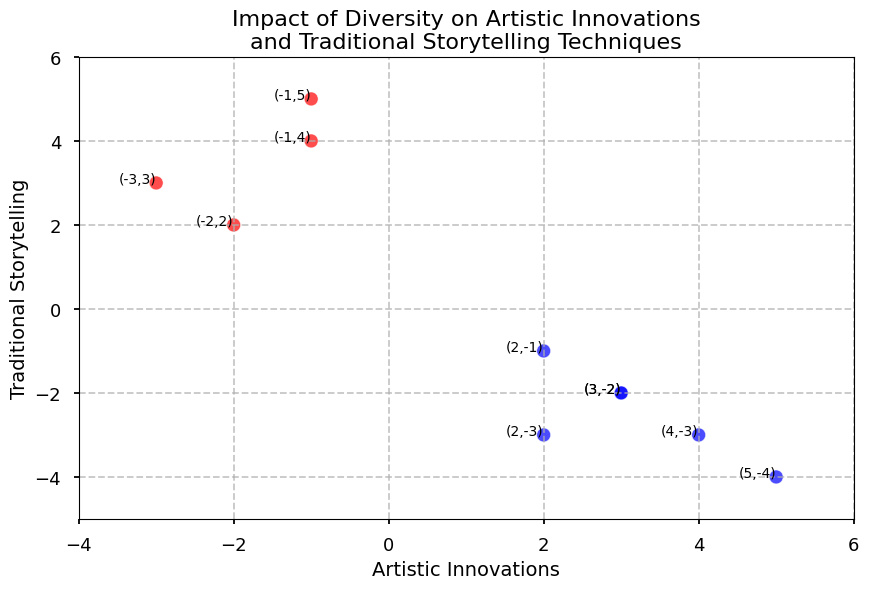What is the point with the highest value of artistic innovations? The point with the highest value of artistic innovations is identified by looking at the x-axis (Artistic Innovations) and finding the point with the maximum x-value. The highest value is 5.
Answer: 5 Are there more points with positive or negative values for traditional storytelling? To answer this, observe the y-axis (Traditional Storytelling) and count the points above and below zero. There are 4 points above zero and 6 points below. Therefore, there are more points with negative values for traditional storytelling.
Answer: More points with negative values Which point has the greatest difference between artistic innovations and traditional storytelling? Calculate the difference for each point: (3, -2)=5, (-1, 5)=6, (4, -3)=7, (2, -1)=3, (-2, 2)=4, (5, -4)=9, (-3, 3)=6, (3, -2)=5, (2, -3)=5, (-1, 4)=5. The greatest difference is at point (5, -4) which equals 9.
Answer: (5, -4) Is there a visible pattern between positive artistic innovations and traditional storytelling? Points with positive artistic innovations are colored blue and they are distributed both above and below zero on the traditional storytelling axis, so there is no clear pattern.
Answer: No clear pattern What's the average value of traditional storytelling for points with positive artistic innovations? Consider points with positive innovations: 3, -2; 4, -3; 2, -1; 5, -4. Sum the traditional values (-2 + -3 + -1 + -4 = -10) and divide by the number of points (4) to find the average: -10/4 = -2.5.
Answer: -2.5 Are there any points where both artistic innovations and traditional storytelling values are negative? Points with negative values for both axes have both x and y values less than zero. Points (-2, 2) and (-3, 3) do not satisfy this, hence there are no points.
Answer: No How many points fall in the fourth quadrant (both values negative for innovations and positive for traditional storytelling)? Points in the fourth quadrant have negative x-values and positive y-values. Identifying these, we find (-1, 5), (-2, 2), (-3, 3), and (-1, 4). There are 4 points.
Answer: 4 What is the ratio of points with positive artistic innovations to the total number of points? Identify points with positive innovations: 4, out of a total of 10 points. The ratio is 4/10. Simplifying this gives 2/5.
Answer: 2/5 Which quadrant has the maximum number of points? The quadrants are as follows: 
- First quadrant: Positive x and y (4, -3); (5, -4)
- Second quadrant: Negative x and positive y (-1, 5); (-2, 2); (-3, 3); (-1, 4)
- Third quadrant: Negative x and y
- Fourth quadrant: Positive x and negative y (3, -2); (2, -1); (2, -3); (3, -2)
Counting the points, the second quadrant has 4 points which is the maximum.
Answer: Second quadrant 